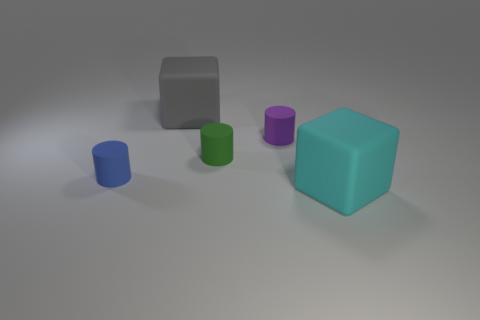Is the big gray matte thing the same shape as the big cyan rubber thing?
Your answer should be very brief. Yes. There is a big thing that is behind the rubber thing that is on the right side of the small purple rubber thing; what is its shape?
Make the answer very short. Cube. Are there any small purple rubber spheres?
Give a very brief answer. No. There is a tiny purple matte thing that is right of the object that is to the left of the large gray matte thing; what number of tiny rubber cylinders are on the left side of it?
Your response must be concise. 2. Does the big cyan thing have the same shape as the large rubber object to the left of the large cyan rubber cube?
Give a very brief answer. Yes. Are there more big cyan matte things than brown matte cylinders?
Give a very brief answer. Yes. Is there any other thing that is the same size as the blue rubber cylinder?
Offer a terse response. Yes. There is a large matte thing behind the cyan matte cube; does it have the same shape as the big cyan rubber thing?
Your response must be concise. Yes. Are there more small objects that are left of the purple thing than small green things?
Ensure brevity in your answer.  Yes. The object in front of the tiny matte object that is to the left of the tiny green matte object is what color?
Your answer should be compact. Cyan. 